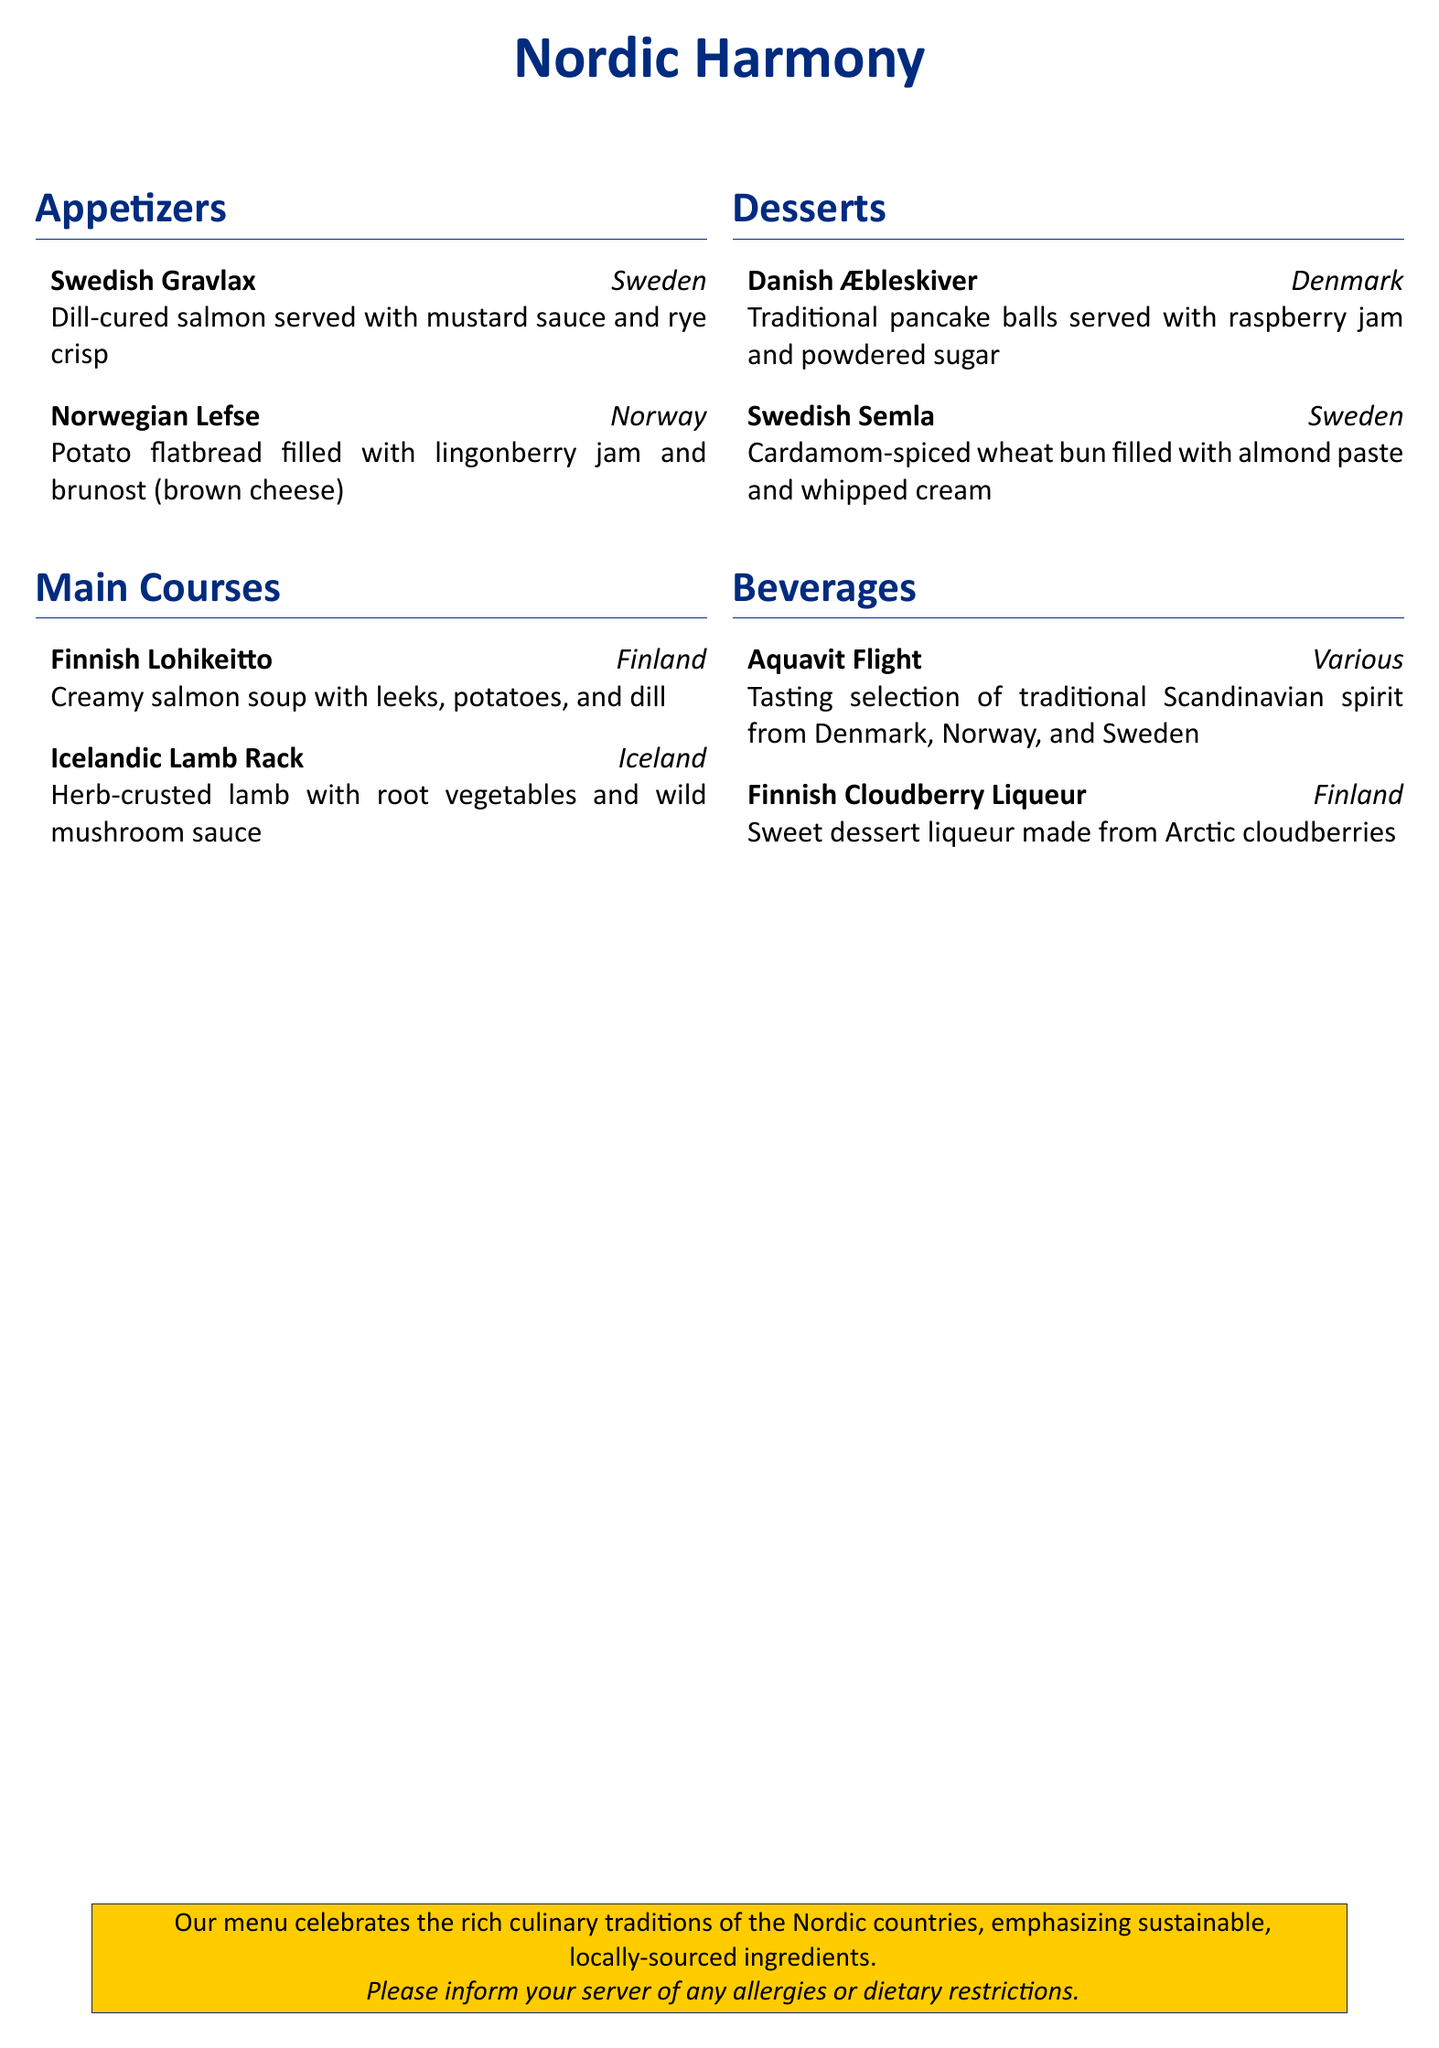What is the name of the menu? The menu is titled "Nordic Harmony."
Answer: Nordic Harmony How many appetizers are listed? There are two appetizers mentioned in the document.
Answer: 2 Which country does the "Lohikeitto" originate from? "Lohikeitto" is a dish from Finland as stated in the menu.
Answer: Finland What dessert is traditionally served with raspberry jam? The dessert served with raspberry jam is called "Æbleskiver."
Answer: Æbleskiver What type of beverage is the "Aquavit Flight"? "Aquavit Flight" is a tasting selection of traditional Scandinavian spirit.
Answer: Tasting selection Which ingredient is used in the "Norwegian Lefse"? The "Norwegian Lefse" is filled with lingonberry jam.
Answer: Lingonberry jam What is the main ingredient in "Danish Æbleskiver"? The main ingredient in "Danish Æbleskiver" is pancake batter.
Answer: Pancake balls How is the "Finnish Cloudberry Liqueur" described? It is described as a sweet dessert liqueur made from Arctic cloudberries.
Answer: Sweet dessert liqueur What common dietary note is mentioned in the menu? The menu mentions informing the server of any allergies or dietary restrictions.
Answer: Allergies or dietary restrictions 